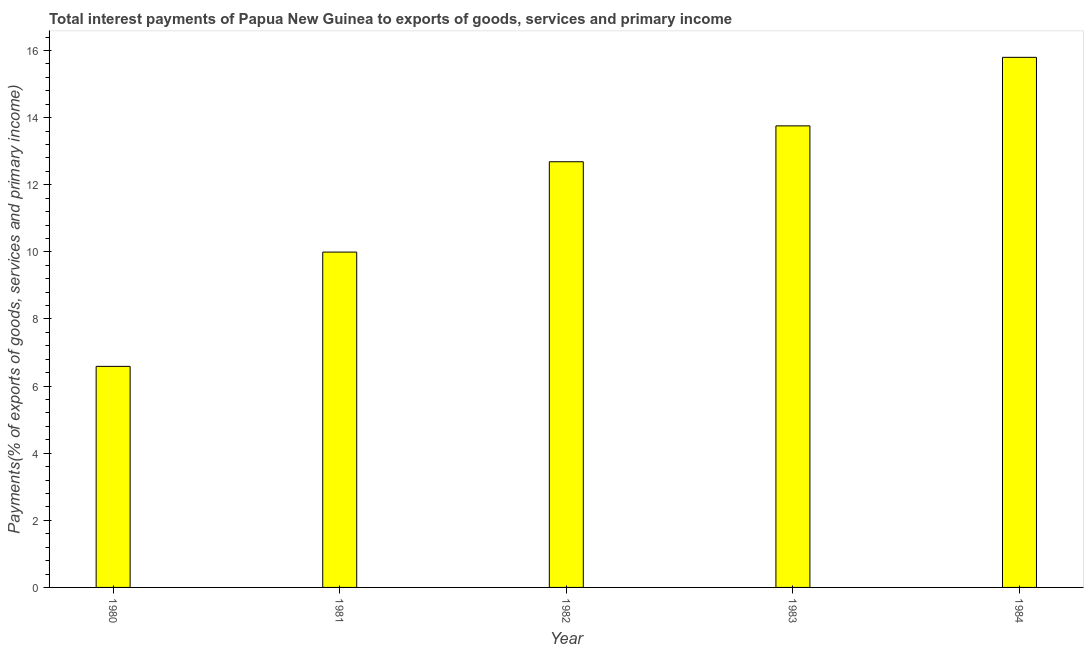Does the graph contain any zero values?
Give a very brief answer. No. What is the title of the graph?
Offer a terse response. Total interest payments of Papua New Guinea to exports of goods, services and primary income. What is the label or title of the X-axis?
Keep it short and to the point. Year. What is the label or title of the Y-axis?
Provide a short and direct response. Payments(% of exports of goods, services and primary income). What is the total interest payments on external debt in 1983?
Provide a succinct answer. 13.75. Across all years, what is the maximum total interest payments on external debt?
Keep it short and to the point. 15.8. Across all years, what is the minimum total interest payments on external debt?
Provide a short and direct response. 6.59. In which year was the total interest payments on external debt minimum?
Your answer should be compact. 1980. What is the sum of the total interest payments on external debt?
Ensure brevity in your answer.  58.82. What is the difference between the total interest payments on external debt in 1980 and 1983?
Make the answer very short. -7.17. What is the average total interest payments on external debt per year?
Your answer should be compact. 11.76. What is the median total interest payments on external debt?
Keep it short and to the point. 12.69. In how many years, is the total interest payments on external debt greater than 9.2 %?
Provide a succinct answer. 4. What is the ratio of the total interest payments on external debt in 1981 to that in 1983?
Offer a very short reply. 0.73. Is the total interest payments on external debt in 1981 less than that in 1984?
Offer a very short reply. Yes. Is the difference between the total interest payments on external debt in 1983 and 1984 greater than the difference between any two years?
Make the answer very short. No. What is the difference between the highest and the second highest total interest payments on external debt?
Your answer should be very brief. 2.04. Is the sum of the total interest payments on external debt in 1980 and 1981 greater than the maximum total interest payments on external debt across all years?
Keep it short and to the point. Yes. What is the difference between the highest and the lowest total interest payments on external debt?
Your answer should be very brief. 9.21. How many bars are there?
Your answer should be compact. 5. Are all the bars in the graph horizontal?
Make the answer very short. No. What is the Payments(% of exports of goods, services and primary income) of 1980?
Your response must be concise. 6.59. What is the Payments(% of exports of goods, services and primary income) of 1981?
Provide a short and direct response. 9.99. What is the Payments(% of exports of goods, services and primary income) of 1982?
Your answer should be very brief. 12.69. What is the Payments(% of exports of goods, services and primary income) in 1983?
Provide a succinct answer. 13.75. What is the Payments(% of exports of goods, services and primary income) of 1984?
Keep it short and to the point. 15.8. What is the difference between the Payments(% of exports of goods, services and primary income) in 1980 and 1981?
Offer a very short reply. -3.41. What is the difference between the Payments(% of exports of goods, services and primary income) in 1980 and 1982?
Keep it short and to the point. -6.1. What is the difference between the Payments(% of exports of goods, services and primary income) in 1980 and 1983?
Your answer should be very brief. -7.17. What is the difference between the Payments(% of exports of goods, services and primary income) in 1980 and 1984?
Offer a terse response. -9.21. What is the difference between the Payments(% of exports of goods, services and primary income) in 1981 and 1982?
Ensure brevity in your answer.  -2.69. What is the difference between the Payments(% of exports of goods, services and primary income) in 1981 and 1983?
Provide a short and direct response. -3.76. What is the difference between the Payments(% of exports of goods, services and primary income) in 1981 and 1984?
Ensure brevity in your answer.  -5.8. What is the difference between the Payments(% of exports of goods, services and primary income) in 1982 and 1983?
Provide a succinct answer. -1.07. What is the difference between the Payments(% of exports of goods, services and primary income) in 1982 and 1984?
Offer a terse response. -3.11. What is the difference between the Payments(% of exports of goods, services and primary income) in 1983 and 1984?
Offer a very short reply. -2.04. What is the ratio of the Payments(% of exports of goods, services and primary income) in 1980 to that in 1981?
Provide a succinct answer. 0.66. What is the ratio of the Payments(% of exports of goods, services and primary income) in 1980 to that in 1982?
Provide a short and direct response. 0.52. What is the ratio of the Payments(% of exports of goods, services and primary income) in 1980 to that in 1983?
Provide a short and direct response. 0.48. What is the ratio of the Payments(% of exports of goods, services and primary income) in 1980 to that in 1984?
Your answer should be very brief. 0.42. What is the ratio of the Payments(% of exports of goods, services and primary income) in 1981 to that in 1982?
Your response must be concise. 0.79. What is the ratio of the Payments(% of exports of goods, services and primary income) in 1981 to that in 1983?
Provide a succinct answer. 0.73. What is the ratio of the Payments(% of exports of goods, services and primary income) in 1981 to that in 1984?
Your response must be concise. 0.63. What is the ratio of the Payments(% of exports of goods, services and primary income) in 1982 to that in 1983?
Offer a very short reply. 0.92. What is the ratio of the Payments(% of exports of goods, services and primary income) in 1982 to that in 1984?
Offer a very short reply. 0.8. What is the ratio of the Payments(% of exports of goods, services and primary income) in 1983 to that in 1984?
Give a very brief answer. 0.87. 